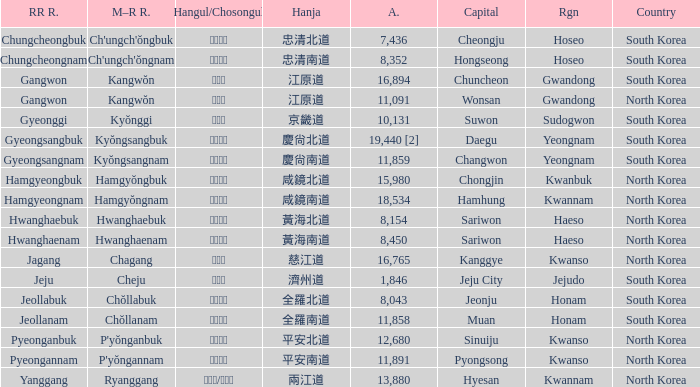Which country has a city with a Hanja of 平安北道? North Korea. 